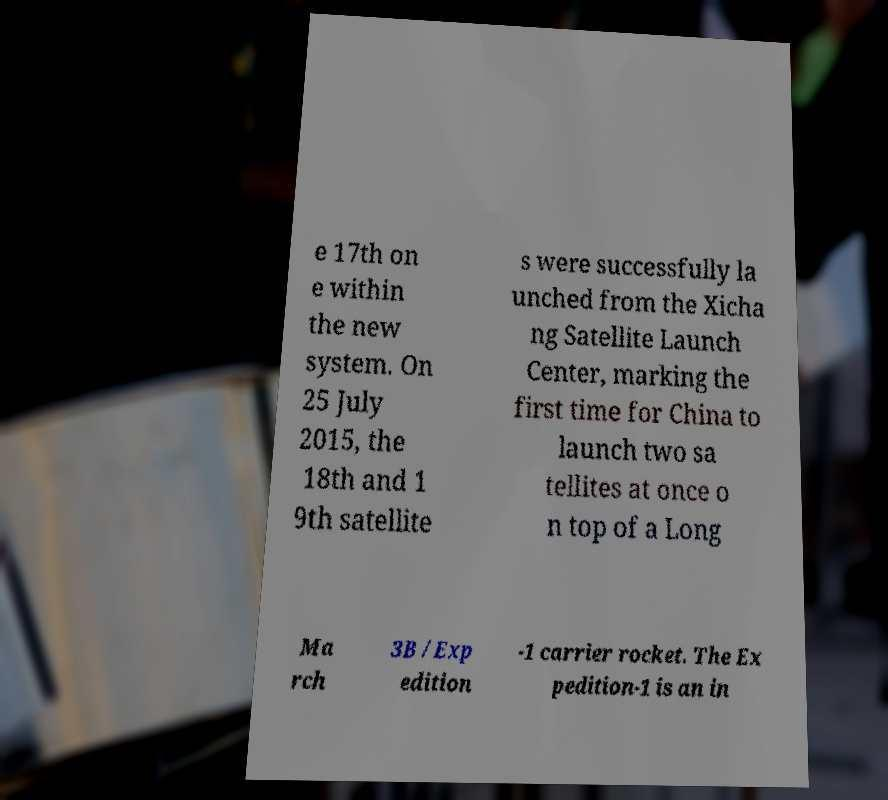What messages or text are displayed in this image? I need them in a readable, typed format. e 17th on e within the new system. On 25 July 2015, the 18th and 1 9th satellite s were successfully la unched from the Xicha ng Satellite Launch Center, marking the first time for China to launch two sa tellites at once o n top of a Long Ma rch 3B /Exp edition -1 carrier rocket. The Ex pedition-1 is an in 